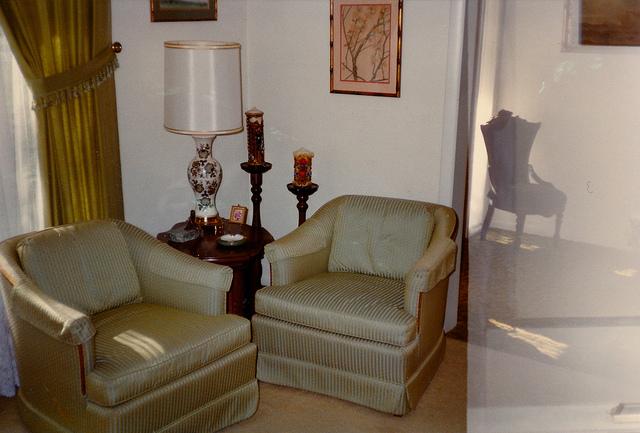What stands on the pedestals by the wall?
Short answer required. Candles. How many chairs are there?
Short answer required. 3. Are the curtains open?
Quick response, please. Yes. 